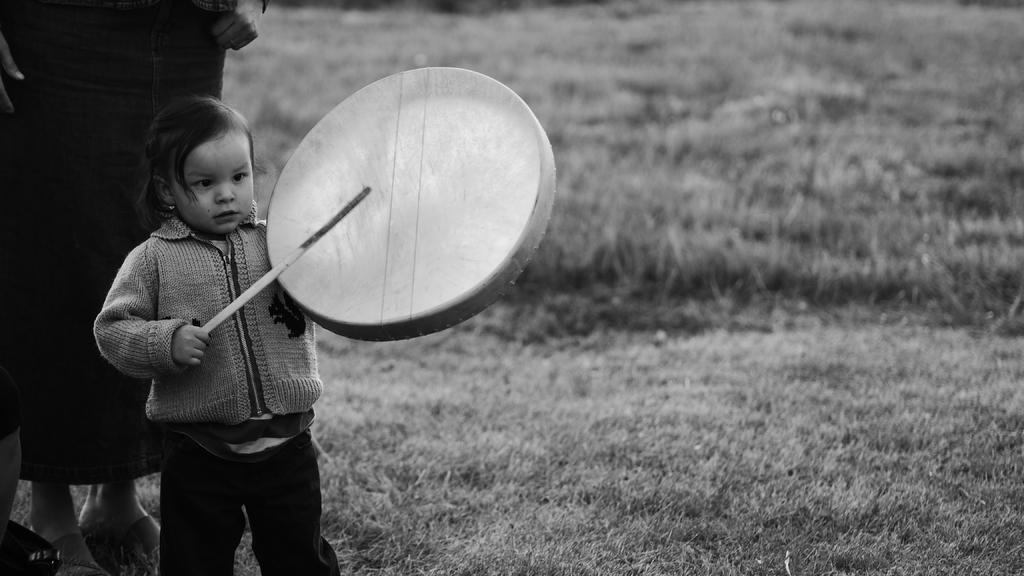What is the person in the image holding? The person is holding a drum in the image. What is the person using to play the drum? The person is holding a stick to play the drum. Can you describe the position of the second person in the image? There is another person behind the first person in the image. What can be seen in the background of the image? There is grass visible in the background of the image. What type of silk material is being used to make the drum in the image? There is no mention of silk or any specific material used to make the drum in the image. 